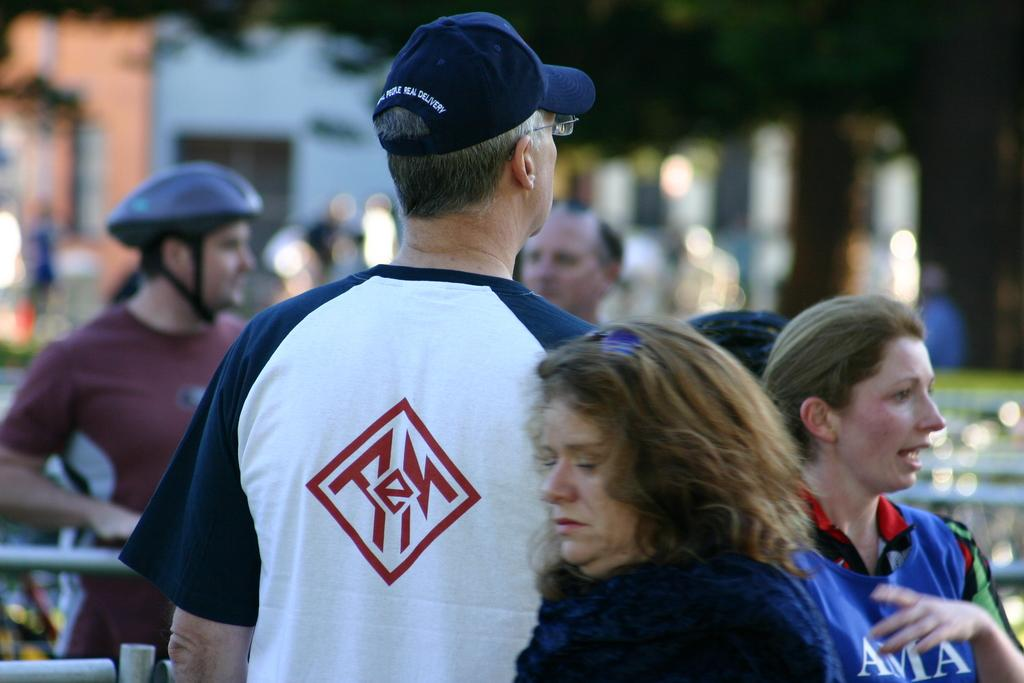Provide a one-sentence caption for the provided image. A man in a blue baseball hat wears a shirt with an "E" on the back. 